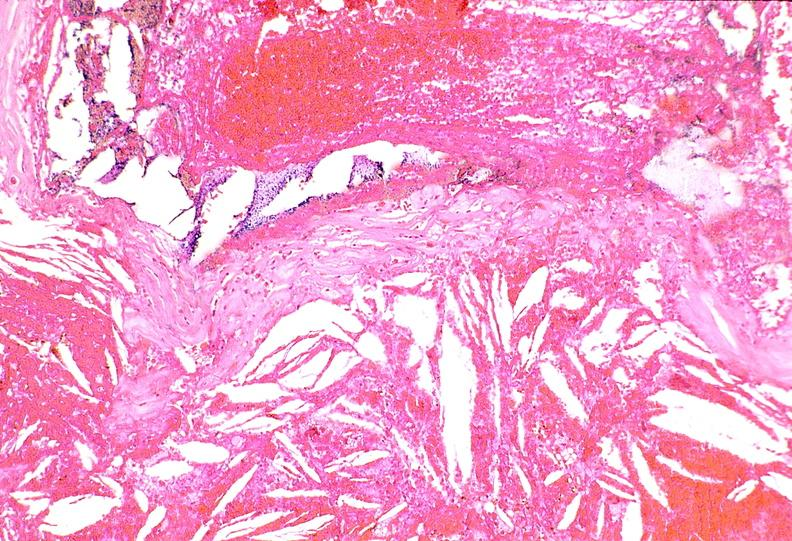s another fiber other frame present?
Answer the question using a single word or phrase. No 